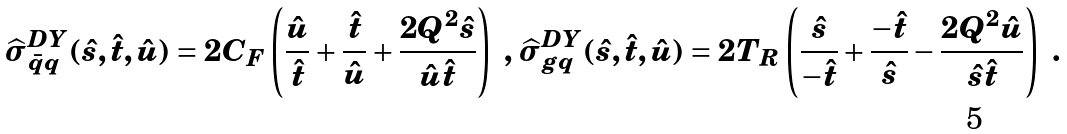<formula> <loc_0><loc_0><loc_500><loc_500>\widehat { \sigma } _ { \bar { q } q } ^ { D Y } ( \hat { s } , \hat { t } , \hat { u } ) = 2 C _ { F } \left ( \frac { \hat { u } } { \hat { t } } + \frac { \hat { t } } { \hat { u } } + \frac { 2 Q ^ { 2 } \hat { s } } { \hat { u } \hat { t } } \right ) \ , \, \widehat { \sigma } _ { g q } ^ { D Y } ( \hat { s } , \hat { t } , \hat { u } ) = 2 T _ { R } \left ( \frac { \hat { s } } { - \hat { t } } + \frac { - \hat { t } } { \hat { s } } - \frac { 2 Q ^ { 2 } \hat { u } } { \hat { s } \hat { t } } \right ) \ .</formula> 